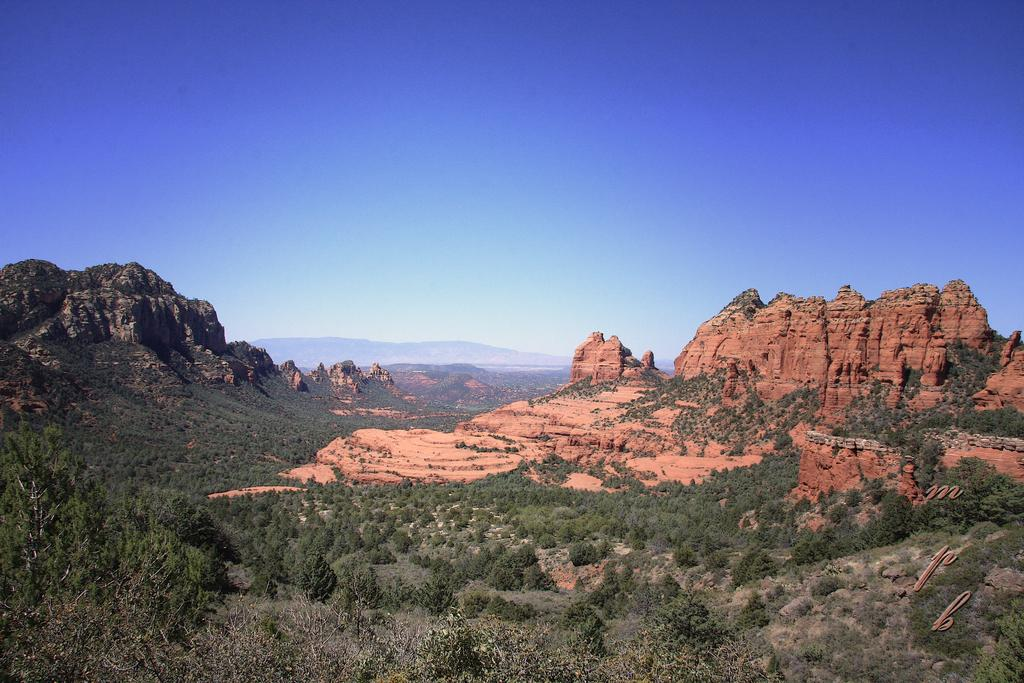What type of landscape is depicted in the image? The image features hills and trees. What color is the sky in the image? The sky is blue in the image. Can you tell me how many credits the horse received for ploughing the field in the image? There is no horse or ploughing activity present in the image; it features hills, trees, and a blue sky. 